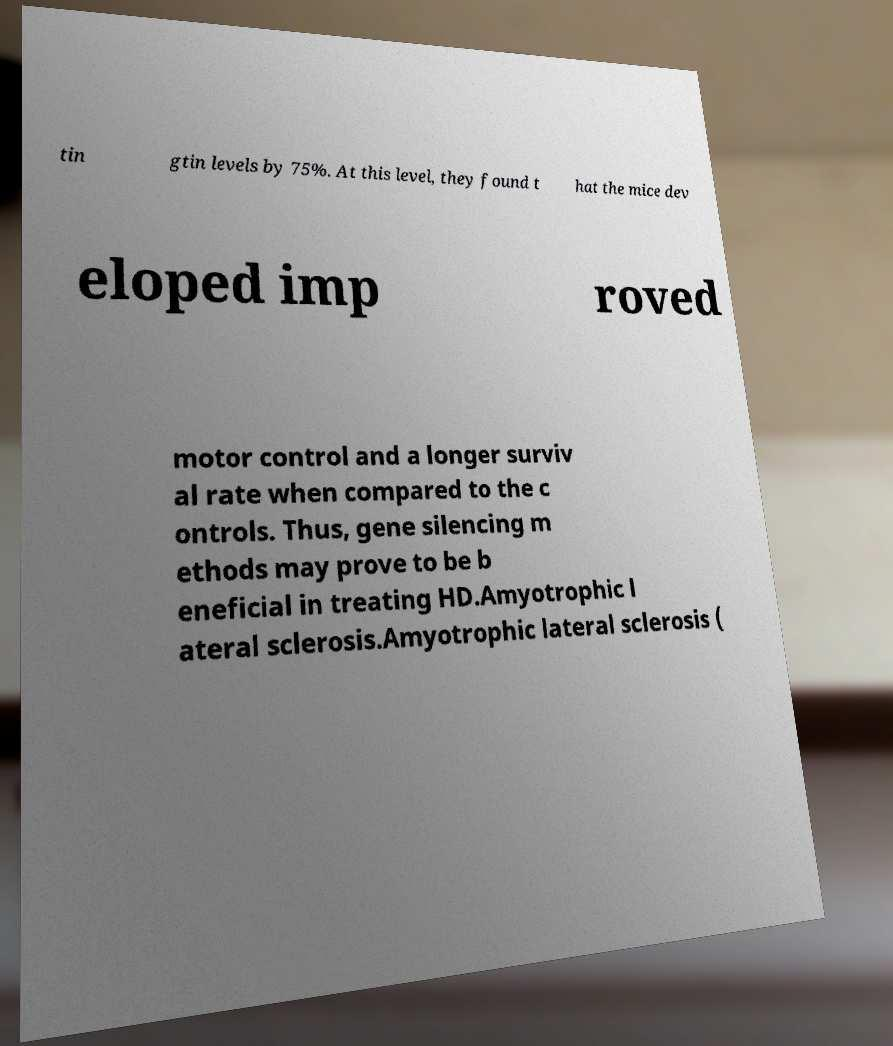For documentation purposes, I need the text within this image transcribed. Could you provide that? tin gtin levels by 75%. At this level, they found t hat the mice dev eloped imp roved motor control and a longer surviv al rate when compared to the c ontrols. Thus, gene silencing m ethods may prove to be b eneficial in treating HD.Amyotrophic l ateral sclerosis.Amyotrophic lateral sclerosis ( 